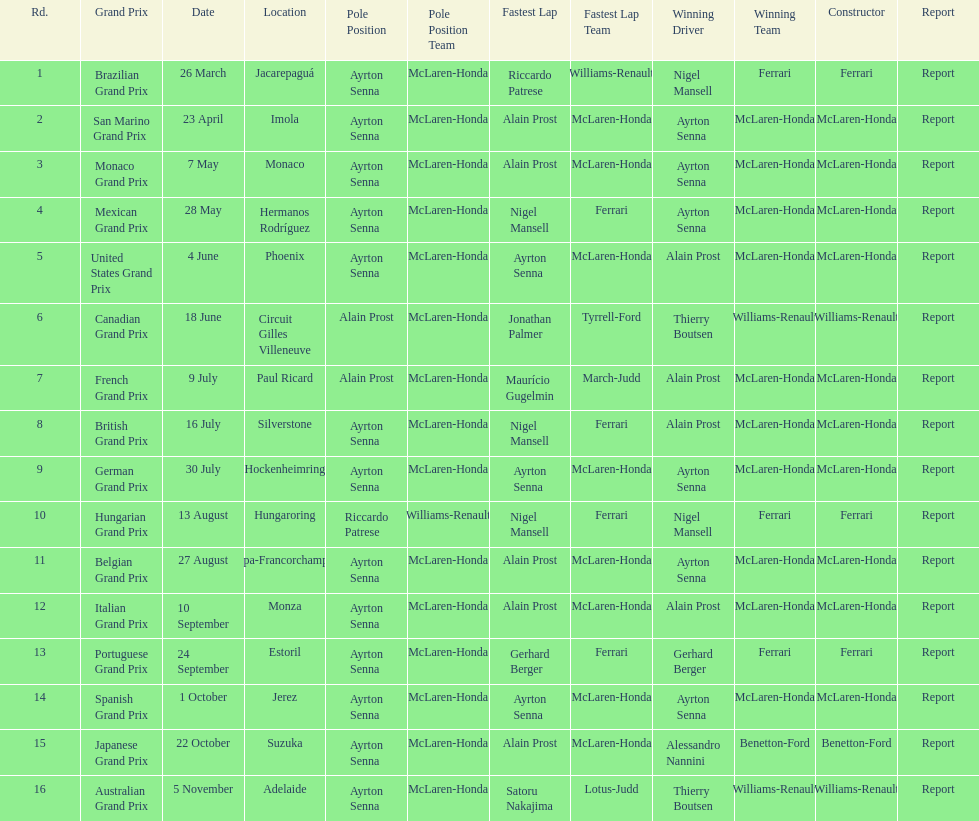How many races occurred before alain prost won a pole position? 5. 